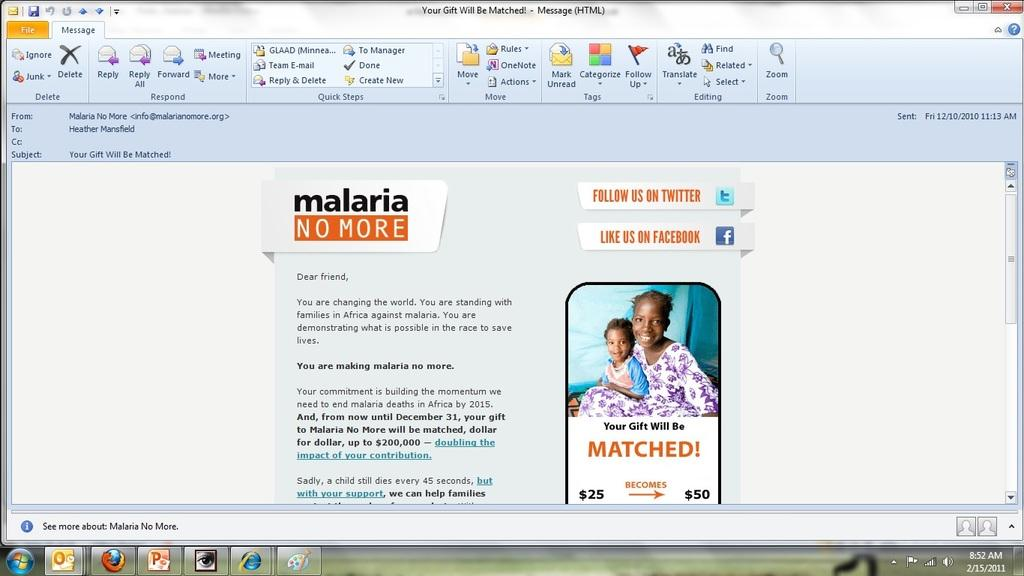Provide a one-sentence caption for the provided image. a screenshot of a website giving information for malaria prevention. 